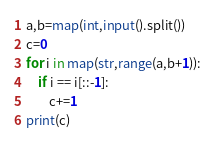Convert code to text. <code><loc_0><loc_0><loc_500><loc_500><_Python_>a,b=map(int,input().split())
c=0
for i in map(str,range(a,b+1)):
    if i == i[::-1]:
        c+=1
print(c)
</code> 